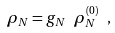Convert formula to latex. <formula><loc_0><loc_0><loc_500><loc_500>\rho _ { N } = g _ { N } \ \rho ^ { ( 0 ) } _ { N } \ ,</formula> 